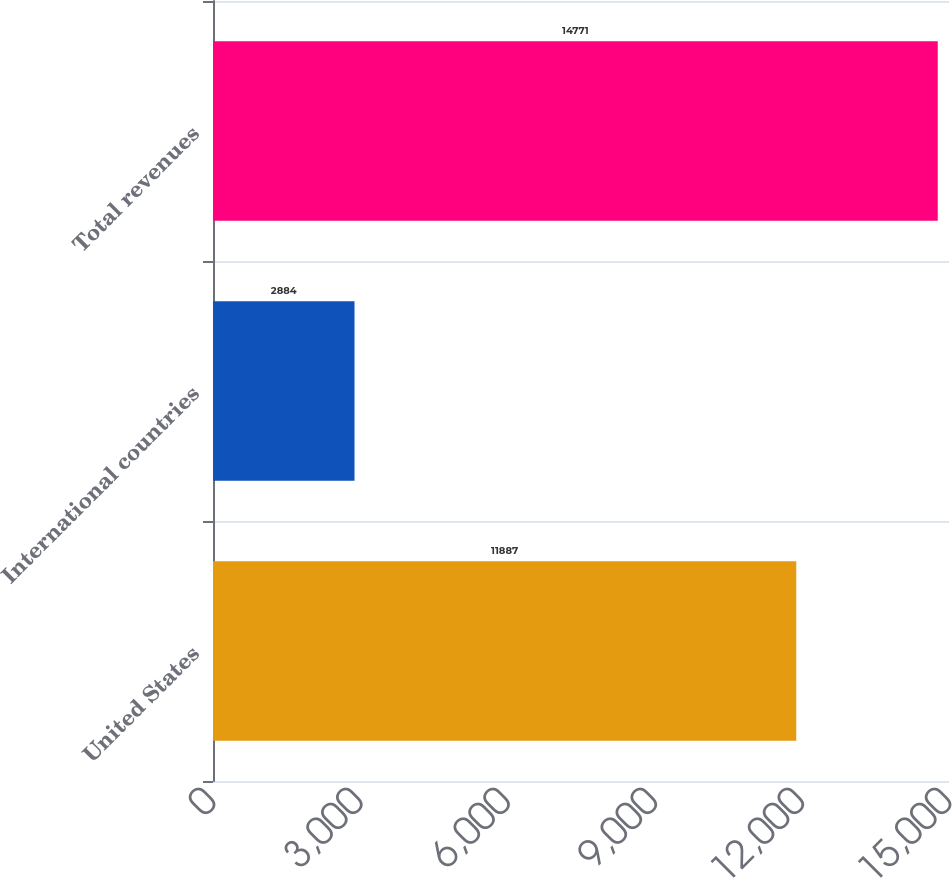Convert chart. <chart><loc_0><loc_0><loc_500><loc_500><bar_chart><fcel>United States<fcel>International countries<fcel>Total revenues<nl><fcel>11887<fcel>2884<fcel>14771<nl></chart> 